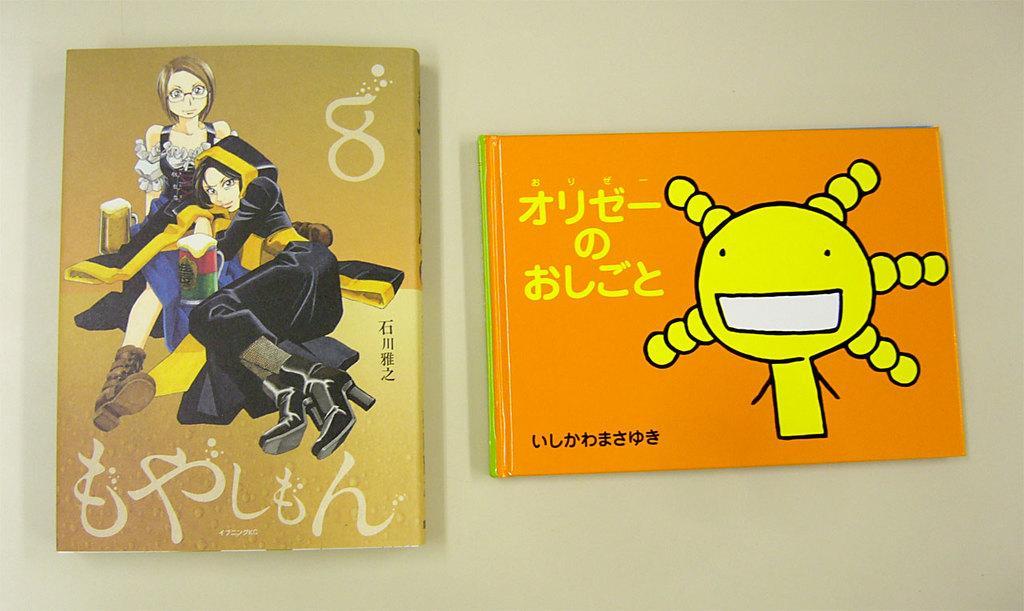Can you describe this image briefly? In this image, we can see books on the table. 